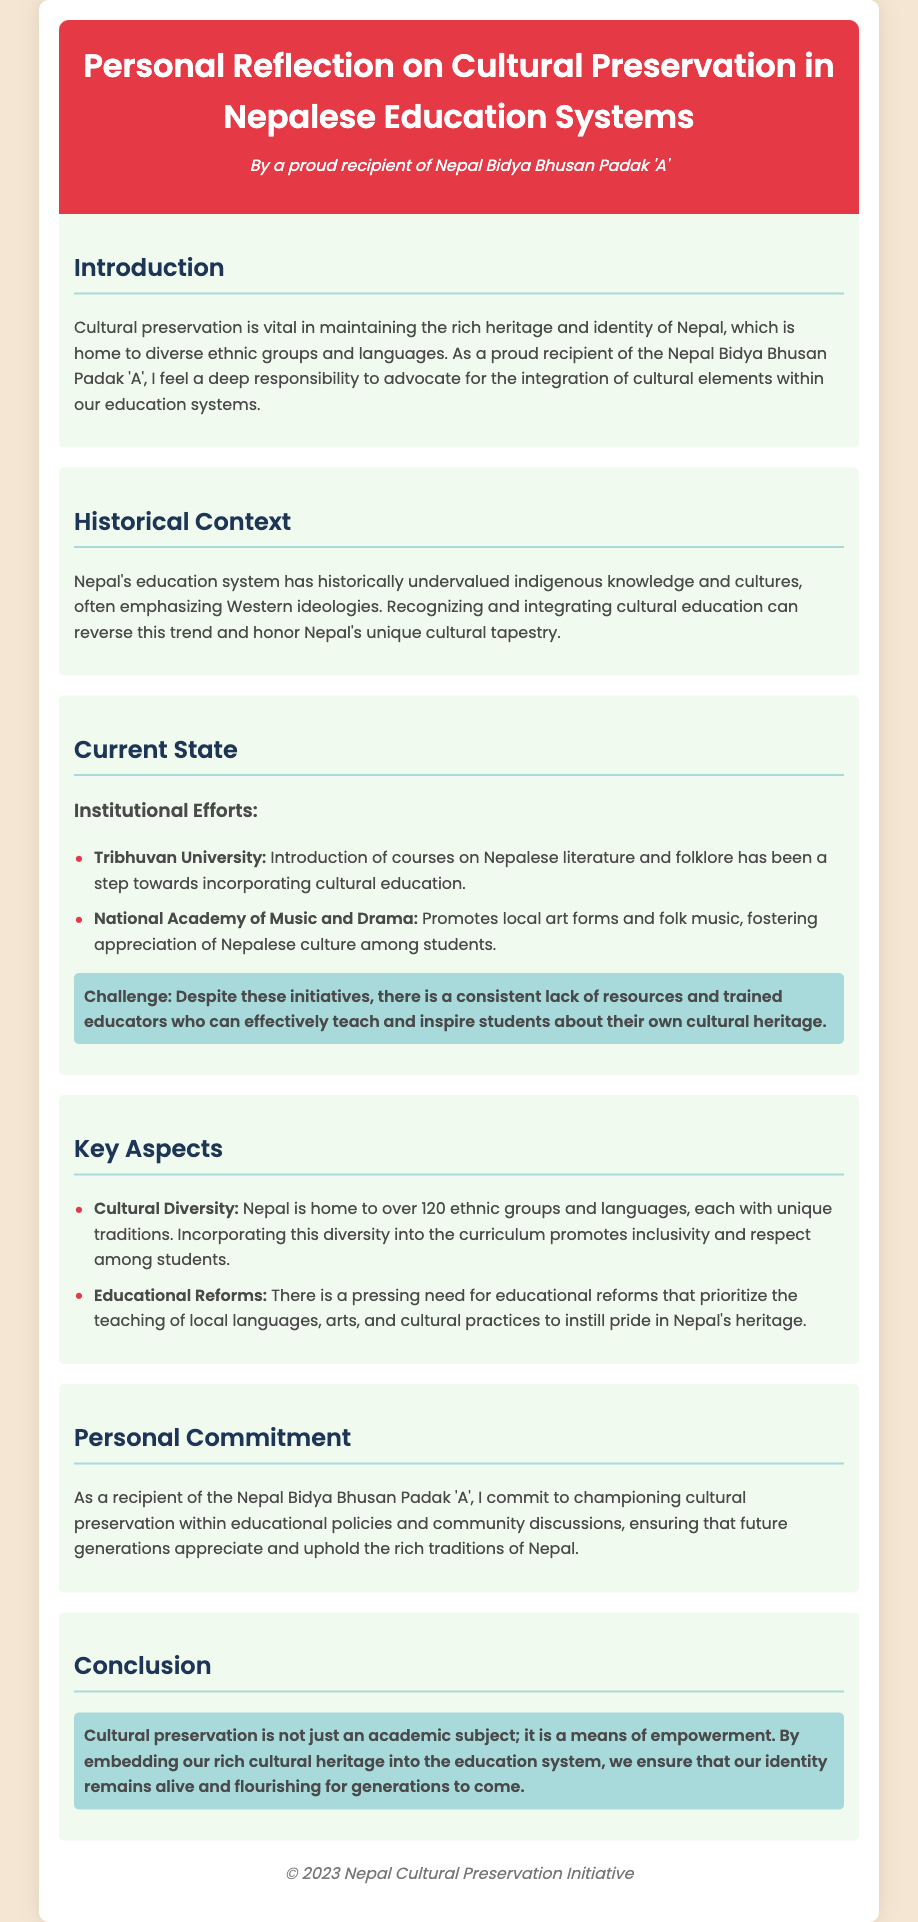What is the title of the document? The title is stated in the header section of the document, which highlights the focus on cultural preservation.
Answer: Personal Reflection on Cultural Preservation in Nepalese Education Systems Who is the author of the note? The author is mentioned in the header, indicating their recognition and proud identity.
Answer: A proud recipient of Nepal Bidya Bhusan Padak 'A' What is the primary focus of the note? The introductory paragraph defines the central theme of the reflection regarding cultural preservation in education.
Answer: Cultural preservation Which institution introduced courses on Nepalese literature? The document lists specific institutions and their contributions to cultural education.
Answer: Tribhuvan University What challenge is highlighted in the current state of cultural education? The note identifies a significant issue faced by educational initiatives related to culture in Nepal.
Answer: Lack of resources and trained educators How many ethnic groups are mentioned as being in Nepal? The note references the rich diversity of ethnicities when discussing cultural aspects in education.
Answer: Over 120 What is the author's personal commitment? The author expresses a specific promise related to their role and advocacy in cultural matters.
Answer: Championing cultural preservation What does the author consider essential for future generations? The conclusion emphasizes an important outcome related to cultural identity and education.
Answer: Identity remains alive and flourishing What is stated as crucial for educational reforms? The key aspects section outlines what is needed to improve the educational system concerning culture.
Answer: Teaching of local languages, arts, and cultural practices 